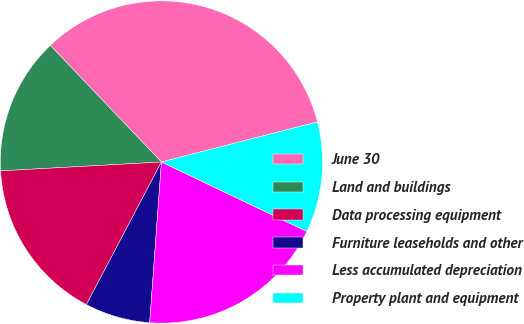<chart> <loc_0><loc_0><loc_500><loc_500><pie_chart><fcel>June 30<fcel>Land and buildings<fcel>Data processing equipment<fcel>Furniture leaseholds and other<fcel>Less accumulated depreciation<fcel>Property plant and equipment<nl><fcel>33.11%<fcel>13.76%<fcel>16.41%<fcel>6.55%<fcel>19.07%<fcel>11.1%<nl></chart> 